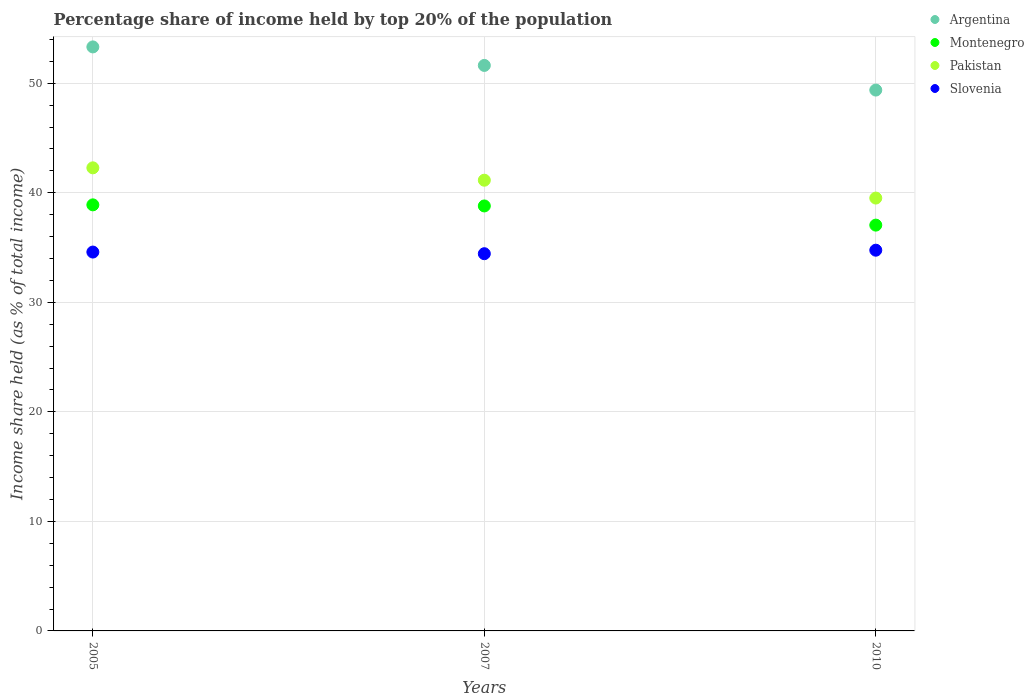Is the number of dotlines equal to the number of legend labels?
Offer a terse response. Yes. What is the percentage share of income held by top 20% of the population in Pakistan in 2010?
Give a very brief answer. 39.52. Across all years, what is the maximum percentage share of income held by top 20% of the population in Montenegro?
Make the answer very short. 38.9. Across all years, what is the minimum percentage share of income held by top 20% of the population in Pakistan?
Give a very brief answer. 39.52. In which year was the percentage share of income held by top 20% of the population in Slovenia minimum?
Provide a succinct answer. 2007. What is the total percentage share of income held by top 20% of the population in Argentina in the graph?
Keep it short and to the point. 154.33. What is the difference between the percentage share of income held by top 20% of the population in Montenegro in 2007 and that in 2010?
Your answer should be compact. 1.75. What is the difference between the percentage share of income held by top 20% of the population in Slovenia in 2010 and the percentage share of income held by top 20% of the population in Argentina in 2007?
Offer a terse response. -16.87. What is the average percentage share of income held by top 20% of the population in Pakistan per year?
Provide a succinct answer. 40.98. In the year 2007, what is the difference between the percentage share of income held by top 20% of the population in Slovenia and percentage share of income held by top 20% of the population in Pakistan?
Your response must be concise. -6.71. In how many years, is the percentage share of income held by top 20% of the population in Montenegro greater than 2 %?
Ensure brevity in your answer.  3. What is the ratio of the percentage share of income held by top 20% of the population in Slovenia in 2007 to that in 2010?
Ensure brevity in your answer.  0.99. What is the difference between the highest and the second highest percentage share of income held by top 20% of the population in Pakistan?
Ensure brevity in your answer.  1.13. What is the difference between the highest and the lowest percentage share of income held by top 20% of the population in Slovenia?
Ensure brevity in your answer.  0.32. In how many years, is the percentage share of income held by top 20% of the population in Pakistan greater than the average percentage share of income held by top 20% of the population in Pakistan taken over all years?
Offer a terse response. 2. Is the sum of the percentage share of income held by top 20% of the population in Slovenia in 2007 and 2010 greater than the maximum percentage share of income held by top 20% of the population in Montenegro across all years?
Provide a short and direct response. Yes. Is it the case that in every year, the sum of the percentage share of income held by top 20% of the population in Argentina and percentage share of income held by top 20% of the population in Slovenia  is greater than the sum of percentage share of income held by top 20% of the population in Montenegro and percentage share of income held by top 20% of the population in Pakistan?
Your answer should be compact. Yes. Is it the case that in every year, the sum of the percentage share of income held by top 20% of the population in Montenegro and percentage share of income held by top 20% of the population in Pakistan  is greater than the percentage share of income held by top 20% of the population in Argentina?
Your answer should be compact. Yes. Does the percentage share of income held by top 20% of the population in Slovenia monotonically increase over the years?
Keep it short and to the point. No. Is the percentage share of income held by top 20% of the population in Argentina strictly greater than the percentage share of income held by top 20% of the population in Montenegro over the years?
Your answer should be very brief. Yes. Is the percentage share of income held by top 20% of the population in Slovenia strictly less than the percentage share of income held by top 20% of the population in Montenegro over the years?
Make the answer very short. Yes. How many dotlines are there?
Your answer should be compact. 4. What is the difference between two consecutive major ticks on the Y-axis?
Your answer should be very brief. 10. Does the graph contain any zero values?
Keep it short and to the point. No. What is the title of the graph?
Your answer should be very brief. Percentage share of income held by top 20% of the population. Does "Oman" appear as one of the legend labels in the graph?
Make the answer very short. No. What is the label or title of the X-axis?
Give a very brief answer. Years. What is the label or title of the Y-axis?
Make the answer very short. Income share held (as % of total income). What is the Income share held (as % of total income) in Argentina in 2005?
Give a very brief answer. 53.32. What is the Income share held (as % of total income) in Montenegro in 2005?
Give a very brief answer. 38.9. What is the Income share held (as % of total income) in Pakistan in 2005?
Your response must be concise. 42.28. What is the Income share held (as % of total income) of Slovenia in 2005?
Make the answer very short. 34.59. What is the Income share held (as % of total income) in Argentina in 2007?
Your response must be concise. 51.63. What is the Income share held (as % of total income) in Montenegro in 2007?
Provide a short and direct response. 38.8. What is the Income share held (as % of total income) in Pakistan in 2007?
Offer a terse response. 41.15. What is the Income share held (as % of total income) in Slovenia in 2007?
Your answer should be compact. 34.44. What is the Income share held (as % of total income) in Argentina in 2010?
Keep it short and to the point. 49.38. What is the Income share held (as % of total income) in Montenegro in 2010?
Give a very brief answer. 37.05. What is the Income share held (as % of total income) of Pakistan in 2010?
Offer a terse response. 39.52. What is the Income share held (as % of total income) of Slovenia in 2010?
Give a very brief answer. 34.76. Across all years, what is the maximum Income share held (as % of total income) of Argentina?
Offer a very short reply. 53.32. Across all years, what is the maximum Income share held (as % of total income) in Montenegro?
Your response must be concise. 38.9. Across all years, what is the maximum Income share held (as % of total income) in Pakistan?
Your response must be concise. 42.28. Across all years, what is the maximum Income share held (as % of total income) in Slovenia?
Give a very brief answer. 34.76. Across all years, what is the minimum Income share held (as % of total income) of Argentina?
Keep it short and to the point. 49.38. Across all years, what is the minimum Income share held (as % of total income) of Montenegro?
Your response must be concise. 37.05. Across all years, what is the minimum Income share held (as % of total income) in Pakistan?
Ensure brevity in your answer.  39.52. Across all years, what is the minimum Income share held (as % of total income) in Slovenia?
Your answer should be compact. 34.44. What is the total Income share held (as % of total income) in Argentina in the graph?
Provide a succinct answer. 154.33. What is the total Income share held (as % of total income) in Montenegro in the graph?
Ensure brevity in your answer.  114.75. What is the total Income share held (as % of total income) in Pakistan in the graph?
Ensure brevity in your answer.  122.95. What is the total Income share held (as % of total income) in Slovenia in the graph?
Offer a terse response. 103.79. What is the difference between the Income share held (as % of total income) in Argentina in 2005 and that in 2007?
Your answer should be compact. 1.69. What is the difference between the Income share held (as % of total income) in Montenegro in 2005 and that in 2007?
Give a very brief answer. 0.1. What is the difference between the Income share held (as % of total income) in Pakistan in 2005 and that in 2007?
Ensure brevity in your answer.  1.13. What is the difference between the Income share held (as % of total income) in Slovenia in 2005 and that in 2007?
Make the answer very short. 0.15. What is the difference between the Income share held (as % of total income) in Argentina in 2005 and that in 2010?
Your answer should be very brief. 3.94. What is the difference between the Income share held (as % of total income) in Montenegro in 2005 and that in 2010?
Make the answer very short. 1.85. What is the difference between the Income share held (as % of total income) of Pakistan in 2005 and that in 2010?
Your answer should be compact. 2.76. What is the difference between the Income share held (as % of total income) of Slovenia in 2005 and that in 2010?
Make the answer very short. -0.17. What is the difference between the Income share held (as % of total income) of Argentina in 2007 and that in 2010?
Offer a terse response. 2.25. What is the difference between the Income share held (as % of total income) of Montenegro in 2007 and that in 2010?
Make the answer very short. 1.75. What is the difference between the Income share held (as % of total income) of Pakistan in 2007 and that in 2010?
Make the answer very short. 1.63. What is the difference between the Income share held (as % of total income) in Slovenia in 2007 and that in 2010?
Provide a short and direct response. -0.32. What is the difference between the Income share held (as % of total income) in Argentina in 2005 and the Income share held (as % of total income) in Montenegro in 2007?
Keep it short and to the point. 14.52. What is the difference between the Income share held (as % of total income) of Argentina in 2005 and the Income share held (as % of total income) of Pakistan in 2007?
Your answer should be compact. 12.17. What is the difference between the Income share held (as % of total income) of Argentina in 2005 and the Income share held (as % of total income) of Slovenia in 2007?
Ensure brevity in your answer.  18.88. What is the difference between the Income share held (as % of total income) of Montenegro in 2005 and the Income share held (as % of total income) of Pakistan in 2007?
Offer a terse response. -2.25. What is the difference between the Income share held (as % of total income) in Montenegro in 2005 and the Income share held (as % of total income) in Slovenia in 2007?
Your answer should be compact. 4.46. What is the difference between the Income share held (as % of total income) of Pakistan in 2005 and the Income share held (as % of total income) of Slovenia in 2007?
Make the answer very short. 7.84. What is the difference between the Income share held (as % of total income) of Argentina in 2005 and the Income share held (as % of total income) of Montenegro in 2010?
Your response must be concise. 16.27. What is the difference between the Income share held (as % of total income) of Argentina in 2005 and the Income share held (as % of total income) of Slovenia in 2010?
Offer a terse response. 18.56. What is the difference between the Income share held (as % of total income) in Montenegro in 2005 and the Income share held (as % of total income) in Pakistan in 2010?
Provide a succinct answer. -0.62. What is the difference between the Income share held (as % of total income) in Montenegro in 2005 and the Income share held (as % of total income) in Slovenia in 2010?
Ensure brevity in your answer.  4.14. What is the difference between the Income share held (as % of total income) of Pakistan in 2005 and the Income share held (as % of total income) of Slovenia in 2010?
Your answer should be very brief. 7.52. What is the difference between the Income share held (as % of total income) in Argentina in 2007 and the Income share held (as % of total income) in Montenegro in 2010?
Ensure brevity in your answer.  14.58. What is the difference between the Income share held (as % of total income) of Argentina in 2007 and the Income share held (as % of total income) of Pakistan in 2010?
Give a very brief answer. 12.11. What is the difference between the Income share held (as % of total income) of Argentina in 2007 and the Income share held (as % of total income) of Slovenia in 2010?
Provide a succinct answer. 16.87. What is the difference between the Income share held (as % of total income) of Montenegro in 2007 and the Income share held (as % of total income) of Pakistan in 2010?
Provide a succinct answer. -0.72. What is the difference between the Income share held (as % of total income) in Montenegro in 2007 and the Income share held (as % of total income) in Slovenia in 2010?
Provide a short and direct response. 4.04. What is the difference between the Income share held (as % of total income) of Pakistan in 2007 and the Income share held (as % of total income) of Slovenia in 2010?
Make the answer very short. 6.39. What is the average Income share held (as % of total income) in Argentina per year?
Your response must be concise. 51.44. What is the average Income share held (as % of total income) of Montenegro per year?
Make the answer very short. 38.25. What is the average Income share held (as % of total income) of Pakistan per year?
Your response must be concise. 40.98. What is the average Income share held (as % of total income) of Slovenia per year?
Give a very brief answer. 34.6. In the year 2005, what is the difference between the Income share held (as % of total income) in Argentina and Income share held (as % of total income) in Montenegro?
Offer a very short reply. 14.42. In the year 2005, what is the difference between the Income share held (as % of total income) of Argentina and Income share held (as % of total income) of Pakistan?
Keep it short and to the point. 11.04. In the year 2005, what is the difference between the Income share held (as % of total income) in Argentina and Income share held (as % of total income) in Slovenia?
Make the answer very short. 18.73. In the year 2005, what is the difference between the Income share held (as % of total income) in Montenegro and Income share held (as % of total income) in Pakistan?
Provide a short and direct response. -3.38. In the year 2005, what is the difference between the Income share held (as % of total income) of Montenegro and Income share held (as % of total income) of Slovenia?
Ensure brevity in your answer.  4.31. In the year 2005, what is the difference between the Income share held (as % of total income) in Pakistan and Income share held (as % of total income) in Slovenia?
Offer a terse response. 7.69. In the year 2007, what is the difference between the Income share held (as % of total income) in Argentina and Income share held (as % of total income) in Montenegro?
Your response must be concise. 12.83. In the year 2007, what is the difference between the Income share held (as % of total income) of Argentina and Income share held (as % of total income) of Pakistan?
Make the answer very short. 10.48. In the year 2007, what is the difference between the Income share held (as % of total income) in Argentina and Income share held (as % of total income) in Slovenia?
Provide a short and direct response. 17.19. In the year 2007, what is the difference between the Income share held (as % of total income) in Montenegro and Income share held (as % of total income) in Pakistan?
Keep it short and to the point. -2.35. In the year 2007, what is the difference between the Income share held (as % of total income) in Montenegro and Income share held (as % of total income) in Slovenia?
Your response must be concise. 4.36. In the year 2007, what is the difference between the Income share held (as % of total income) in Pakistan and Income share held (as % of total income) in Slovenia?
Provide a succinct answer. 6.71. In the year 2010, what is the difference between the Income share held (as % of total income) of Argentina and Income share held (as % of total income) of Montenegro?
Provide a succinct answer. 12.33. In the year 2010, what is the difference between the Income share held (as % of total income) in Argentina and Income share held (as % of total income) in Pakistan?
Your answer should be compact. 9.86. In the year 2010, what is the difference between the Income share held (as % of total income) in Argentina and Income share held (as % of total income) in Slovenia?
Ensure brevity in your answer.  14.62. In the year 2010, what is the difference between the Income share held (as % of total income) of Montenegro and Income share held (as % of total income) of Pakistan?
Your response must be concise. -2.47. In the year 2010, what is the difference between the Income share held (as % of total income) in Montenegro and Income share held (as % of total income) in Slovenia?
Offer a very short reply. 2.29. In the year 2010, what is the difference between the Income share held (as % of total income) of Pakistan and Income share held (as % of total income) of Slovenia?
Provide a short and direct response. 4.76. What is the ratio of the Income share held (as % of total income) of Argentina in 2005 to that in 2007?
Ensure brevity in your answer.  1.03. What is the ratio of the Income share held (as % of total income) of Pakistan in 2005 to that in 2007?
Keep it short and to the point. 1.03. What is the ratio of the Income share held (as % of total income) of Argentina in 2005 to that in 2010?
Provide a succinct answer. 1.08. What is the ratio of the Income share held (as % of total income) in Montenegro in 2005 to that in 2010?
Provide a succinct answer. 1.05. What is the ratio of the Income share held (as % of total income) in Pakistan in 2005 to that in 2010?
Provide a short and direct response. 1.07. What is the ratio of the Income share held (as % of total income) of Slovenia in 2005 to that in 2010?
Ensure brevity in your answer.  1. What is the ratio of the Income share held (as % of total income) of Argentina in 2007 to that in 2010?
Give a very brief answer. 1.05. What is the ratio of the Income share held (as % of total income) of Montenegro in 2007 to that in 2010?
Ensure brevity in your answer.  1.05. What is the ratio of the Income share held (as % of total income) of Pakistan in 2007 to that in 2010?
Your answer should be compact. 1.04. What is the ratio of the Income share held (as % of total income) in Slovenia in 2007 to that in 2010?
Give a very brief answer. 0.99. What is the difference between the highest and the second highest Income share held (as % of total income) of Argentina?
Ensure brevity in your answer.  1.69. What is the difference between the highest and the second highest Income share held (as % of total income) of Montenegro?
Make the answer very short. 0.1. What is the difference between the highest and the second highest Income share held (as % of total income) of Pakistan?
Your response must be concise. 1.13. What is the difference between the highest and the second highest Income share held (as % of total income) of Slovenia?
Your response must be concise. 0.17. What is the difference between the highest and the lowest Income share held (as % of total income) in Argentina?
Provide a succinct answer. 3.94. What is the difference between the highest and the lowest Income share held (as % of total income) in Montenegro?
Make the answer very short. 1.85. What is the difference between the highest and the lowest Income share held (as % of total income) of Pakistan?
Ensure brevity in your answer.  2.76. What is the difference between the highest and the lowest Income share held (as % of total income) in Slovenia?
Provide a short and direct response. 0.32. 